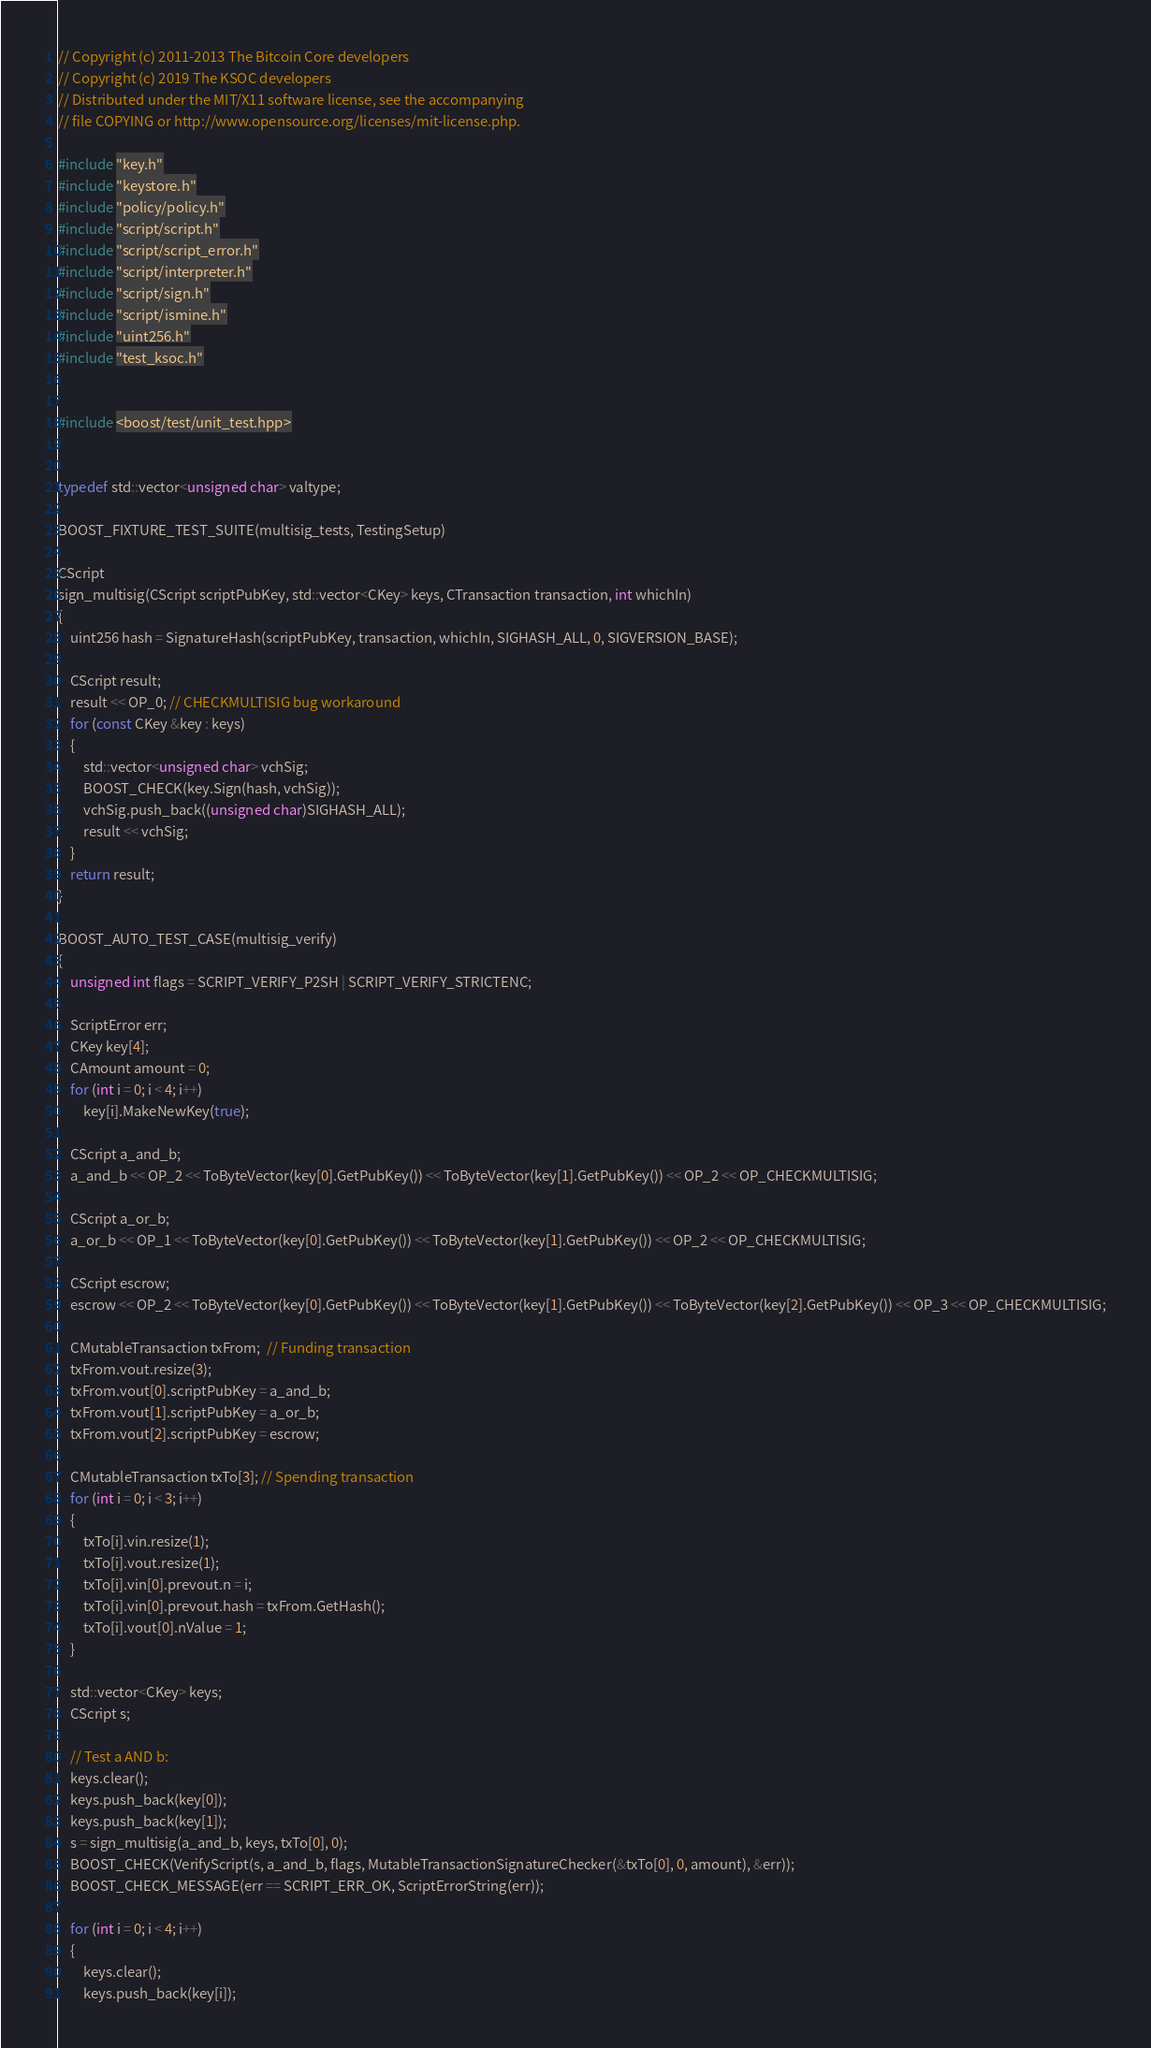<code> <loc_0><loc_0><loc_500><loc_500><_C++_>// Copyright (c) 2011-2013 The Bitcoin Core developers
// Copyright (c) 2019 The KSOC developers
// Distributed under the MIT/X11 software license, see the accompanying
// file COPYING or http://www.opensource.org/licenses/mit-license.php.

#include "key.h"
#include "keystore.h"
#include "policy/policy.h"
#include "script/script.h"
#include "script/script_error.h"
#include "script/interpreter.h"
#include "script/sign.h"
#include "script/ismine.h"
#include "uint256.h"
#include "test_ksoc.h"


#include <boost/test/unit_test.hpp>


typedef std::vector<unsigned char> valtype;

BOOST_FIXTURE_TEST_SUITE(multisig_tests, TestingSetup)

CScript
sign_multisig(CScript scriptPubKey, std::vector<CKey> keys, CTransaction transaction, int whichIn)
{
    uint256 hash = SignatureHash(scriptPubKey, transaction, whichIn, SIGHASH_ALL, 0, SIGVERSION_BASE);

    CScript result;
    result << OP_0; // CHECKMULTISIG bug workaround
    for (const CKey &key : keys)
    {
        std::vector<unsigned char> vchSig;
        BOOST_CHECK(key.Sign(hash, vchSig));
        vchSig.push_back((unsigned char)SIGHASH_ALL);
        result << vchSig;
    }
    return result;
}

BOOST_AUTO_TEST_CASE(multisig_verify)
{
    unsigned int flags = SCRIPT_VERIFY_P2SH | SCRIPT_VERIFY_STRICTENC;

    ScriptError err;
    CKey key[4];
    CAmount amount = 0;
    for (int i = 0; i < 4; i++)
        key[i].MakeNewKey(true);

    CScript a_and_b;
    a_and_b << OP_2 << ToByteVector(key[0].GetPubKey()) << ToByteVector(key[1].GetPubKey()) << OP_2 << OP_CHECKMULTISIG;

    CScript a_or_b;
    a_or_b << OP_1 << ToByteVector(key[0].GetPubKey()) << ToByteVector(key[1].GetPubKey()) << OP_2 << OP_CHECKMULTISIG;

    CScript escrow;
    escrow << OP_2 << ToByteVector(key[0].GetPubKey()) << ToByteVector(key[1].GetPubKey()) << ToByteVector(key[2].GetPubKey()) << OP_3 << OP_CHECKMULTISIG;

    CMutableTransaction txFrom;  // Funding transaction
    txFrom.vout.resize(3);
    txFrom.vout[0].scriptPubKey = a_and_b;
    txFrom.vout[1].scriptPubKey = a_or_b;
    txFrom.vout[2].scriptPubKey = escrow;

    CMutableTransaction txTo[3]; // Spending transaction
    for (int i = 0; i < 3; i++)
    {
        txTo[i].vin.resize(1);
        txTo[i].vout.resize(1);
        txTo[i].vin[0].prevout.n = i;
        txTo[i].vin[0].prevout.hash = txFrom.GetHash();
        txTo[i].vout[0].nValue = 1;
    }

    std::vector<CKey> keys;
    CScript s;

    // Test a AND b:
    keys.clear();
    keys.push_back(key[0]);
    keys.push_back(key[1]);
    s = sign_multisig(a_and_b, keys, txTo[0], 0);
    BOOST_CHECK(VerifyScript(s, a_and_b, flags, MutableTransactionSignatureChecker(&txTo[0], 0, amount), &err));
    BOOST_CHECK_MESSAGE(err == SCRIPT_ERR_OK, ScriptErrorString(err));

    for (int i = 0; i < 4; i++)
    {
        keys.clear();
        keys.push_back(key[i]);</code> 